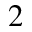Convert formula to latex. <formula><loc_0><loc_0><loc_500><loc_500>_ { 2 }</formula> 